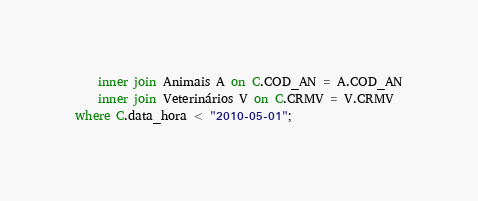<code> <loc_0><loc_0><loc_500><loc_500><_SQL_>    inner join Animais A on C.COD_AN = A.COD_AN
    inner join Veterinários V on C.CRMV = V.CRMV
where C.data_hora < "2010-05-01";</code> 